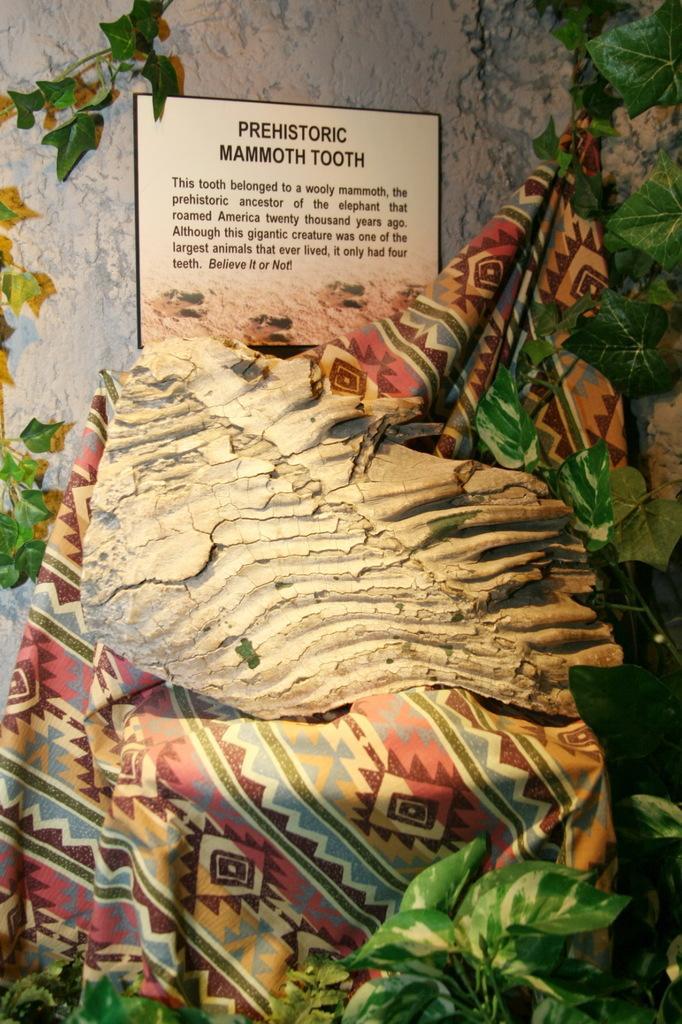In one or two sentences, can you explain what this image depicts? In this image we can see an object on the cloth, beside that we can see the leaves, And we can see text written on the board. And we can see the wall in the background. 